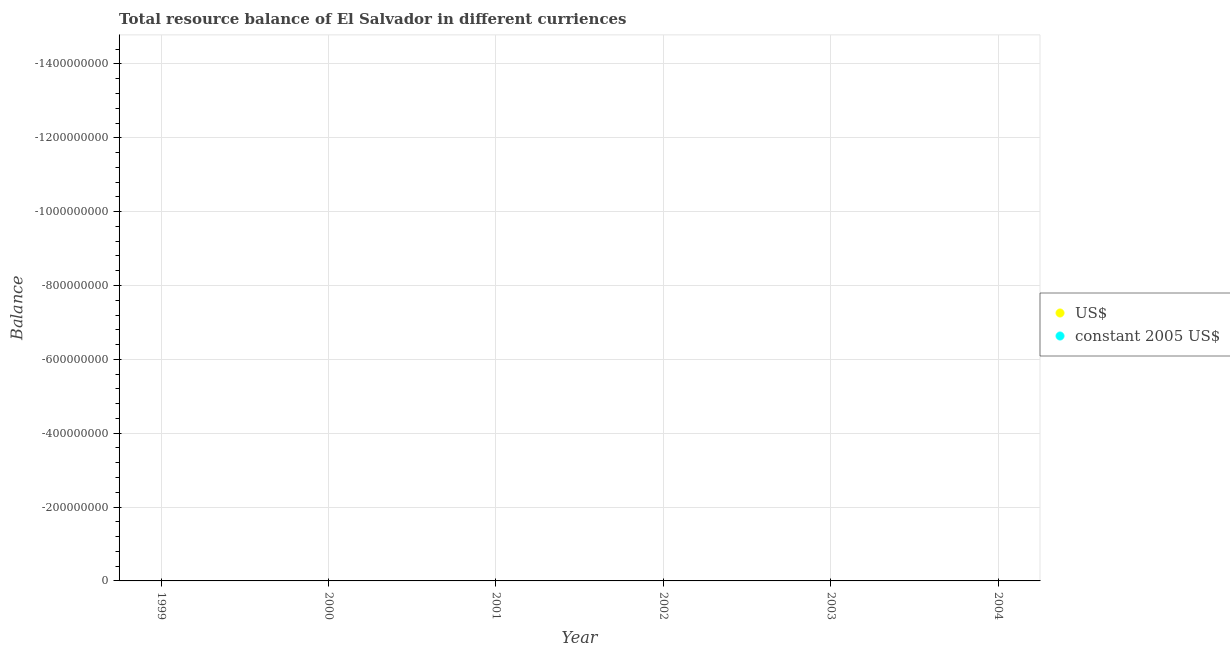What is the resource balance in constant us$ in 2000?
Your response must be concise. 0. What is the difference between the resource balance in constant us$ in 2003 and the resource balance in us$ in 2000?
Your response must be concise. 0. In how many years, is the resource balance in constant us$ greater than the average resource balance in constant us$ taken over all years?
Your answer should be very brief. 0. Does the resource balance in us$ monotonically increase over the years?
Provide a short and direct response. No. Is the resource balance in constant us$ strictly greater than the resource balance in us$ over the years?
Your answer should be very brief. No. Is the resource balance in constant us$ strictly less than the resource balance in us$ over the years?
Your answer should be very brief. No. How many years are there in the graph?
Keep it short and to the point. 6. Does the graph contain grids?
Your answer should be compact. Yes. How many legend labels are there?
Ensure brevity in your answer.  2. What is the title of the graph?
Provide a succinct answer. Total resource balance of El Salvador in different curriences. What is the label or title of the X-axis?
Your answer should be very brief. Year. What is the label or title of the Y-axis?
Keep it short and to the point. Balance. What is the Balance in constant 2005 US$ in 1999?
Keep it short and to the point. 0. What is the Balance of constant 2005 US$ in 2000?
Offer a terse response. 0. What is the Balance in US$ in 2001?
Ensure brevity in your answer.  0. What is the Balance of constant 2005 US$ in 2002?
Your answer should be compact. 0. What is the Balance in US$ in 2003?
Make the answer very short. 0. What is the Balance of constant 2005 US$ in 2003?
Ensure brevity in your answer.  0. What is the Balance of constant 2005 US$ in 2004?
Offer a terse response. 0. What is the total Balance in constant 2005 US$ in the graph?
Make the answer very short. 0. What is the average Balance in constant 2005 US$ per year?
Your answer should be compact. 0. 